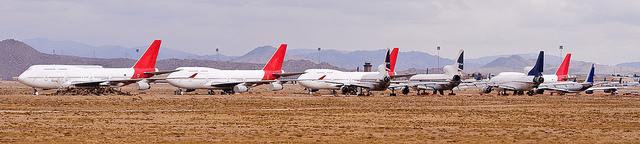Is it likely that the aircraft will be rained on?
Write a very short answer. Yes. Are the airplanes moving?
Quick response, please. No. Which way are the planes pointed?
Short answer required. Left. 